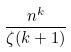Convert formula to latex. <formula><loc_0><loc_0><loc_500><loc_500>\frac { n ^ { k } } { \zeta ( k + 1 ) }</formula> 